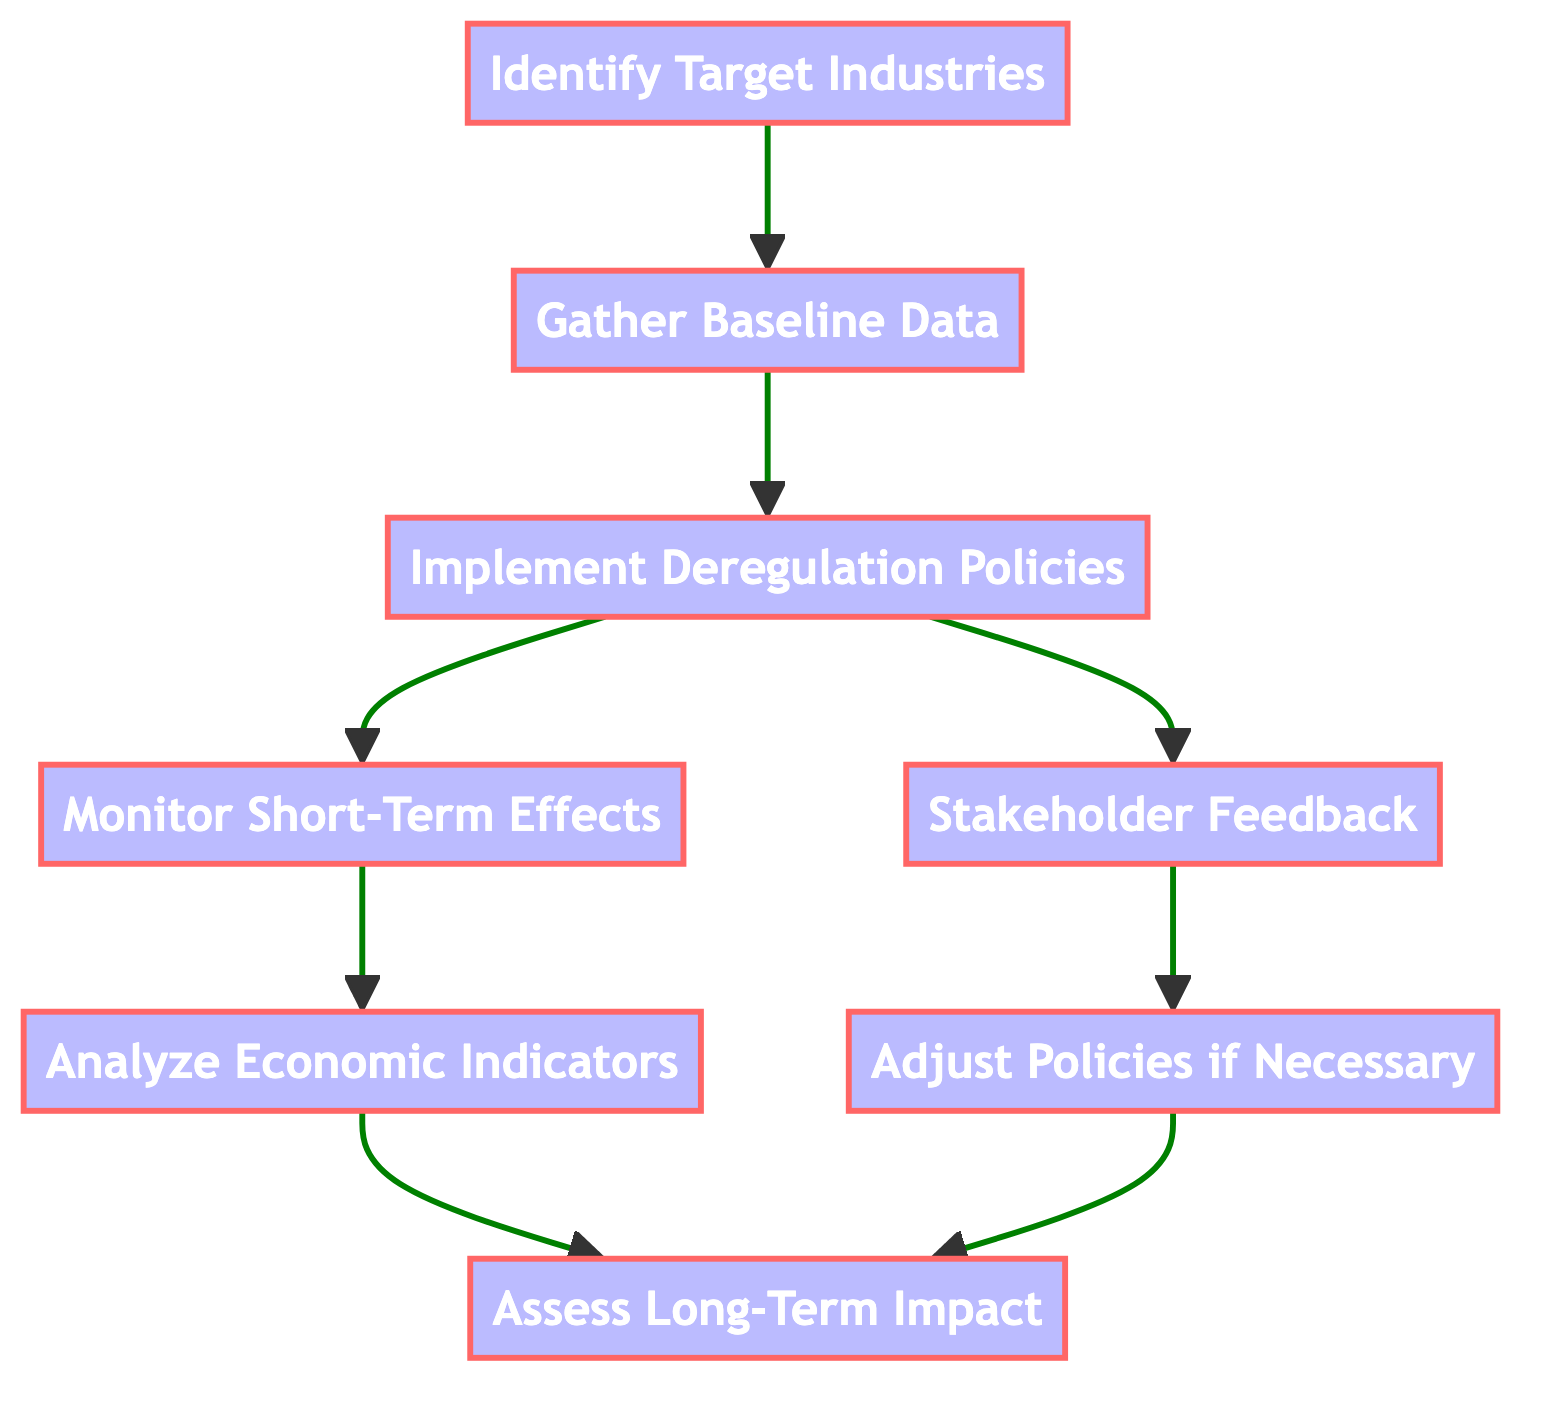What is the first step in the process? The first step is to "Identify Target Industries," which is represented as the first node in the flowchart.
Answer: Identify Target Industries How many nodes are present in the diagram? The diagram contains a total of 8 nodes, each representing a specific step in the impact evaluation process.
Answer: 8 What is the output of the "Gather Baseline Data" node? The "Gather Baseline Data" node outputs the next step, which is "Implement Deregulation Policies," indicated by the arrow pointing to node 3.
Answer: Implement Deregulation Policies Which node follows "Implement Deregulation Policies"? After "Implement Deregulation Policies," two nodes follow: "Monitor Short-Term Effects" and "Stakeholder Feedback," as shown in the diagram with split arrows.
Answer: Monitor Short-Term Effects and Stakeholder Feedback What two analyses happen after monitoring short-term effects and gathering stakeholder feedback? The two analyses that occur afterward are "Analyze Economic Indicators" and "Adjust Policies if Necessary," both leading to the assessment of long-term impact.
Answer: Analyze Economic Indicators and Adjust Policies if Necessary What happens after "Analyze Economic Indicators"? The process continues to "Assess Long-Term Impact," which is the final step as indicated in the flowchart.
Answer: Assess Long-Term Impact Which step involves the collection of pre-deregulation economic data? The step involving the collection of pre-deregulation economic data is "Gather Baseline Data," highlighted in the diagram as the second step.
Answer: Gather Baseline Data What are the two short-term evaluation methods indicated in the diagram? The two short-term evaluation methods indicated are "Monitor Short-Term Effects" and "Stakeholder Feedback," shown as outputs of the "Implement Deregulation Policies" node.
Answer: Monitor Short-Term Effects and Stakeholder Feedback 